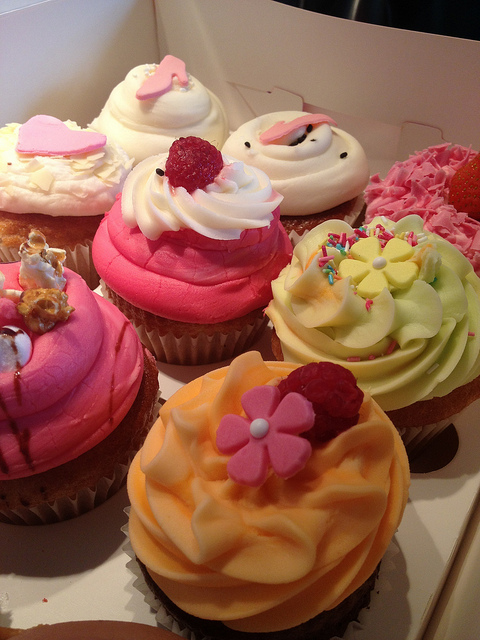How many cupcakes are in the photo? 8 